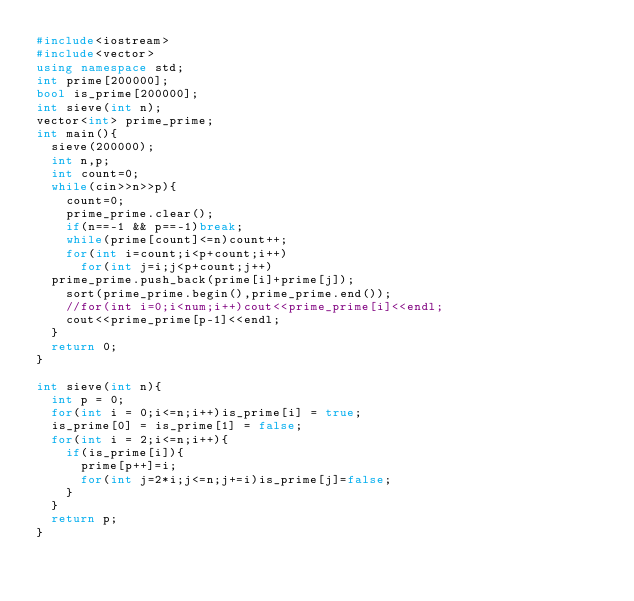Convert code to text. <code><loc_0><loc_0><loc_500><loc_500><_C++_>#include<iostream>
#include<vector>
using namespace std;
int prime[200000];
bool is_prime[200000];
int sieve(int n);
vector<int> prime_prime;
int main(){
  sieve(200000);
  int n,p;
  int count=0;
  while(cin>>n>>p){
    count=0;
    prime_prime.clear();
    if(n==-1 && p==-1)break;
    while(prime[count]<=n)count++;
    for(int i=count;i<p+count;i++)
      for(int j=i;j<p+count;j++)
	prime_prime.push_back(prime[i]+prime[j]);
    sort(prime_prime.begin(),prime_prime.end());
    //for(int i=0;i<num;i++)cout<<prime_prime[i]<<endl;    
    cout<<prime_prime[p-1]<<endl;
  }
  return 0;
}

int sieve(int n){
  int p = 0;
  for(int i = 0;i<=n;i++)is_prime[i] = true;
  is_prime[0] = is_prime[1] = false;
  for(int i = 2;i<=n;i++){
    if(is_prime[i]){
      prime[p++]=i;
      for(int j=2*i;j<=n;j+=i)is_prime[j]=false;
    }
  }
  return p;
}</code> 